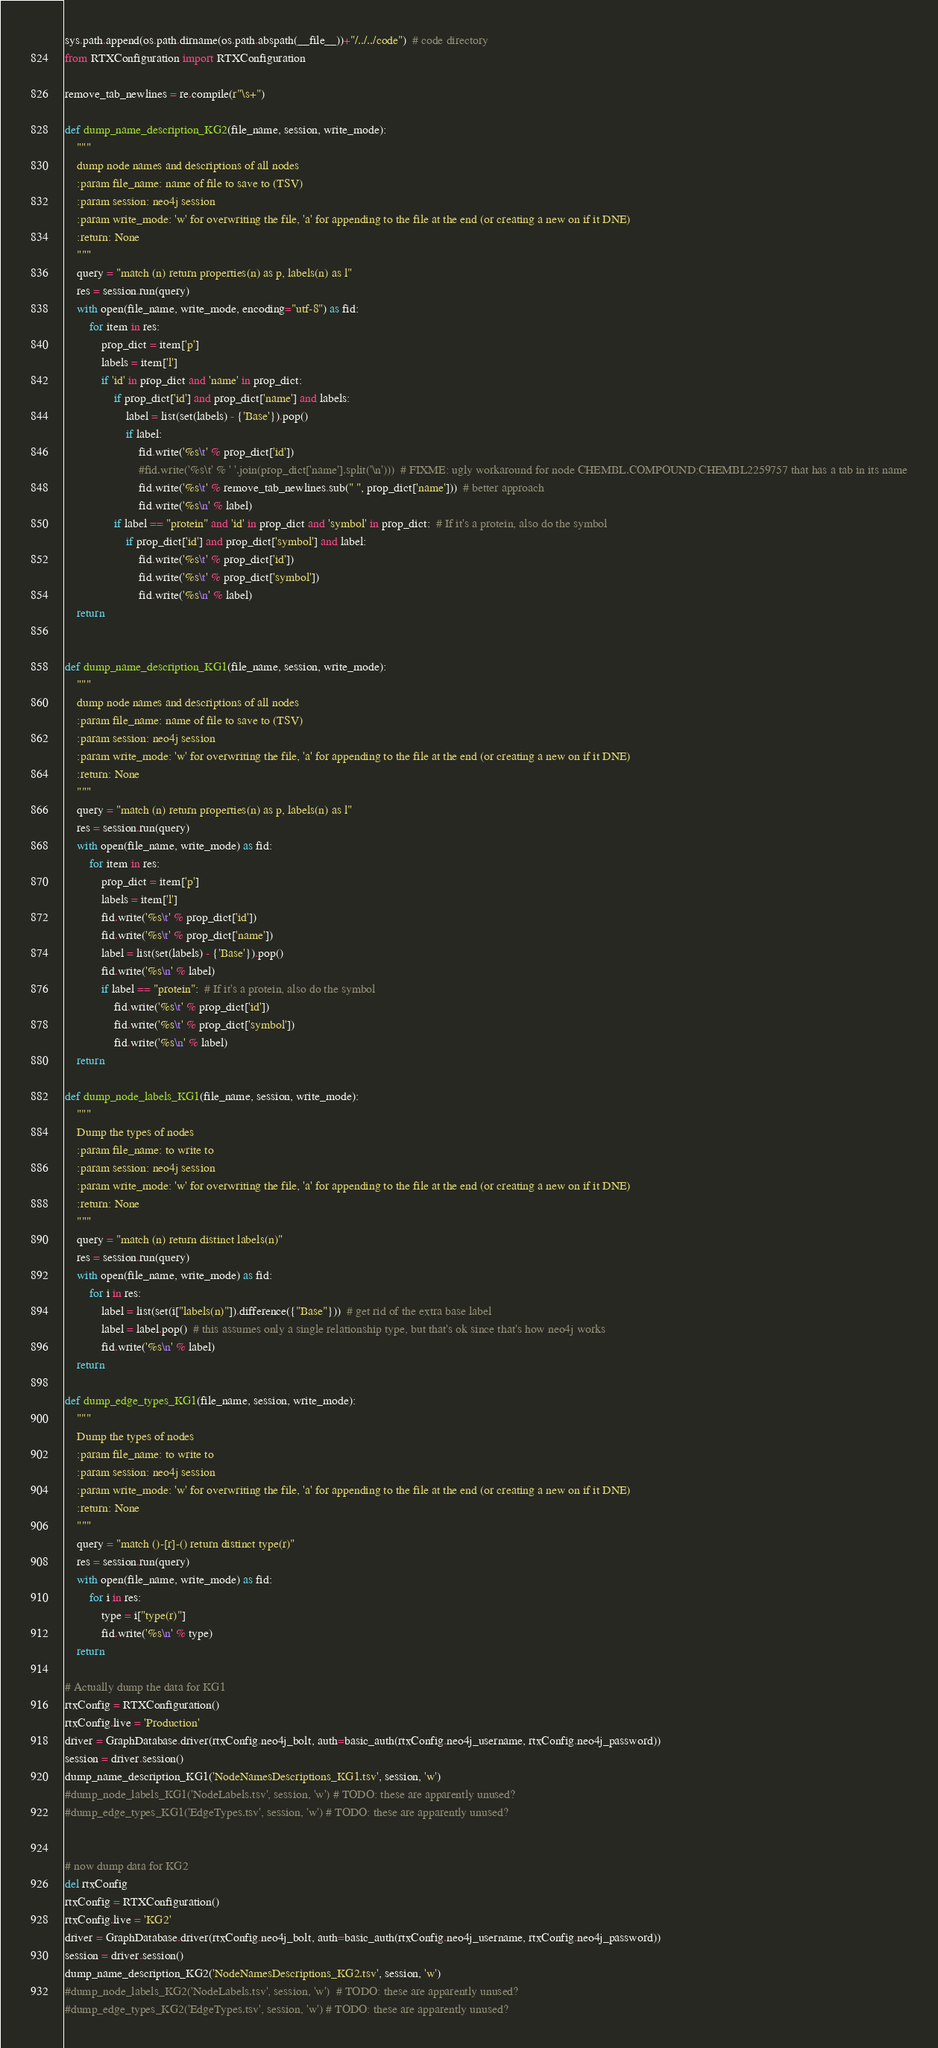<code> <loc_0><loc_0><loc_500><loc_500><_Python_>sys.path.append(os.path.dirname(os.path.abspath(__file__))+"/../../code")  # code directory
from RTXConfiguration import RTXConfiguration

remove_tab_newlines = re.compile(r"\s+")

def dump_name_description_KG2(file_name, session, write_mode):
	"""
	dump node names and descriptions of all nodes
	:param file_name: name of file to save to (TSV)
	:param session: neo4j session
	:param write_mode: 'w' for overwriting the file, 'a' for appending to the file at the end (or creating a new on if it DNE)
	:return: None
	"""
	query = "match (n) return properties(n) as p, labels(n) as l"
	res = session.run(query)
	with open(file_name, write_mode, encoding="utf-8") as fid:
		for item in res:
			prop_dict = item['p']
			labels = item['l']
			if 'id' in prop_dict and 'name' in prop_dict:
				if prop_dict['id'] and prop_dict['name'] and labels:
					label = list(set(labels) - {'Base'}).pop()
					if label:
						fid.write('%s\t' % prop_dict['id'])
						#fid.write('%s\t' % ' '.join(prop_dict['name'].split('\n')))  # FIXME: ugly workaround for node CHEMBL.COMPOUND:CHEMBL2259757 that has a tab in its name
						fid.write('%s\t' % remove_tab_newlines.sub(" ", prop_dict['name']))  # better approach
						fid.write('%s\n' % label)
				if label == "protein" and 'id' in prop_dict and 'symbol' in prop_dict:  # If it's a protein, also do the symbol
					if prop_dict['id'] and prop_dict['symbol'] and label:
						fid.write('%s\t' % prop_dict['id'])
						fid.write('%s\t' % prop_dict['symbol'])
						fid.write('%s\n' % label)
	return


def dump_name_description_KG1(file_name, session, write_mode):
	"""
	dump node names and descriptions of all nodes
	:param file_name: name of file to save to (TSV)
	:param session: neo4j session
	:param write_mode: 'w' for overwriting the file, 'a' for appending to the file at the end (or creating a new on if it DNE)
	:return: None
	"""
	query = "match (n) return properties(n) as p, labels(n) as l"
	res = session.run(query)
	with open(file_name, write_mode) as fid:
		for item in res:
			prop_dict = item['p']
			labels = item['l']
			fid.write('%s\t' % prop_dict['id'])
			fid.write('%s\t' % prop_dict['name'])
			label = list(set(labels) - {'Base'}).pop()
			fid.write('%s\n' % label)
			if label == "protein":  # If it's a protein, also do the symbol
				fid.write('%s\t' % prop_dict['id'])
				fid.write('%s\t' % prop_dict['symbol'])
				fid.write('%s\n' % label)
	return

def dump_node_labels_KG1(file_name, session, write_mode):
	"""
	Dump the types of nodes
	:param file_name: to write to
	:param session: neo4j session
	:param write_mode: 'w' for overwriting the file, 'a' for appending to the file at the end (or creating a new on if it DNE)
	:return: None
	"""
	query = "match (n) return distinct labels(n)"
	res = session.run(query)
	with open(file_name, write_mode) as fid:
		for i in res:
			label = list(set(i["labels(n)"]).difference({"Base"}))  # get rid of the extra base label
			label = label.pop()  # this assumes only a single relationship type, but that's ok since that's how neo4j works
			fid.write('%s\n' % label)
	return

def dump_edge_types_KG1(file_name, session, write_mode):
	"""
	Dump the types of nodes
	:param file_name: to write to
	:param session: neo4j session
	:param write_mode: 'w' for overwriting the file, 'a' for appending to the file at the end (or creating a new on if it DNE)
	:return: None
	"""
	query = "match ()-[r]-() return distinct type(r)"
	res = session.run(query)
	with open(file_name, write_mode) as fid:
		for i in res:
			type = i["type(r)"]
			fid.write('%s\n' % type)
	return

# Actually dump the data for KG1
rtxConfig = RTXConfiguration()
rtxConfig.live = 'Production'
driver = GraphDatabase.driver(rtxConfig.neo4j_bolt, auth=basic_auth(rtxConfig.neo4j_username, rtxConfig.neo4j_password))
session = driver.session()
dump_name_description_KG1('NodeNamesDescriptions_KG1.tsv', session, 'w')
#dump_node_labels_KG1('NodeLabels.tsv', session, 'w') # TODO: these are apparently unused?
#dump_edge_types_KG1('EdgeTypes.tsv', session, 'w') # TODO: these are apparently unused?


# now dump data for KG2
del rtxConfig
rtxConfig = RTXConfiguration()
rtxConfig.live = 'KG2'
driver = GraphDatabase.driver(rtxConfig.neo4j_bolt, auth=basic_auth(rtxConfig.neo4j_username, rtxConfig.neo4j_password))
session = driver.session()
dump_name_description_KG2('NodeNamesDescriptions_KG2.tsv', session, 'w')
#dump_node_labels_KG2('NodeLabels.tsv', session, 'w')  # TODO: these are apparently unused?
#dump_edge_types_KG2('EdgeTypes.tsv', session, 'w') # TODO: these are apparently unused?
</code> 